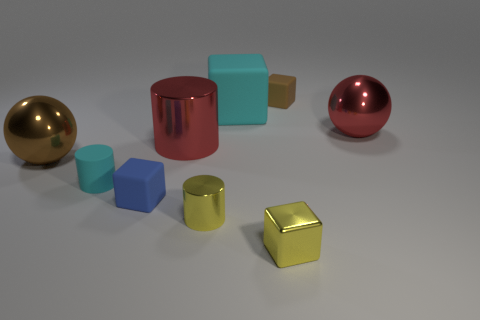The cyan thing that is the same material as the big block is what shape?
Offer a terse response. Cylinder. Are there any other things that have the same color as the tiny shiny cylinder?
Ensure brevity in your answer.  Yes. How many tiny matte things are behind the big thing on the right side of the brown matte thing that is to the right of the small blue object?
Your response must be concise. 1. What number of green things are tiny metal blocks or shiny cylinders?
Offer a terse response. 0. There is a blue object; is its size the same as the yellow object that is to the left of the big block?
Provide a succinct answer. Yes. There is a cyan thing that is the same shape as the tiny brown rubber thing; what is it made of?
Your answer should be very brief. Rubber. What number of other objects are there of the same size as the red shiny cylinder?
Ensure brevity in your answer.  3. What shape is the small object behind the large brown ball in front of the large sphere that is right of the red metal cylinder?
Make the answer very short. Cube. The shiny thing that is behind the yellow cylinder and in front of the big metallic cylinder has what shape?
Make the answer very short. Sphere. What number of things are tiny cyan rubber things or yellow metal things to the left of the big rubber block?
Offer a very short reply. 2. 